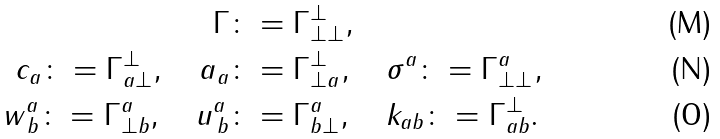<formula> <loc_0><loc_0><loc_500><loc_500>\Gamma \colon & = \Gamma ^ { \perp } _ { \perp \perp } , \\ c _ { a } \colon = \Gamma ^ { \perp } _ { a \perp } , \quad a _ { a } \colon & = \Gamma ^ { \perp } _ { \perp a } , \quad \sigma ^ { a } \colon = \Gamma ^ { a } _ { \perp \perp } , \\ w ^ { a } _ { \, b } \colon = \Gamma ^ { a } _ { \perp b } , \quad u ^ { a } _ { \, b } \colon & = \Gamma ^ { a } _ { b \perp } , \quad k _ { a b } \colon = \Gamma ^ { \perp } _ { a b } .</formula> 